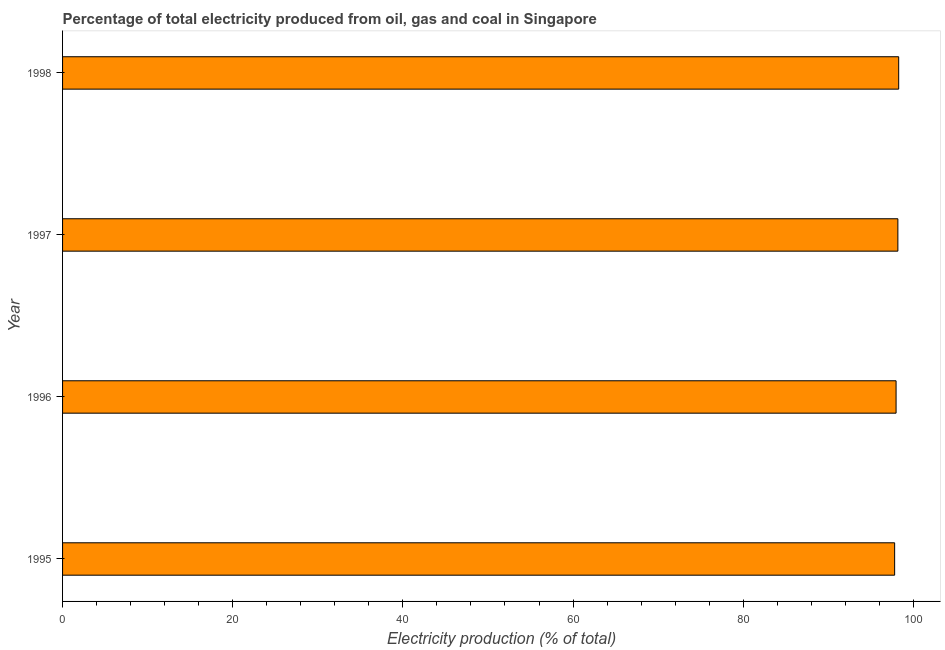Does the graph contain grids?
Keep it short and to the point. No. What is the title of the graph?
Provide a succinct answer. Percentage of total electricity produced from oil, gas and coal in Singapore. What is the label or title of the X-axis?
Give a very brief answer. Electricity production (% of total). What is the electricity production in 1996?
Provide a succinct answer. 97.97. Across all years, what is the maximum electricity production?
Offer a terse response. 98.27. Across all years, what is the minimum electricity production?
Provide a succinct answer. 97.8. In which year was the electricity production minimum?
Ensure brevity in your answer.  1995. What is the sum of the electricity production?
Make the answer very short. 392.22. What is the difference between the electricity production in 1995 and 1997?
Give a very brief answer. -0.38. What is the average electricity production per year?
Make the answer very short. 98.05. What is the median electricity production?
Offer a terse response. 98.07. In how many years, is the electricity production greater than 76 %?
Your answer should be compact. 4. Is the electricity production in 1995 less than that in 1998?
Your answer should be compact. Yes. What is the difference between the highest and the second highest electricity production?
Your response must be concise. 0.1. What is the difference between the highest and the lowest electricity production?
Your answer should be very brief. 0.48. In how many years, is the electricity production greater than the average electricity production taken over all years?
Provide a short and direct response. 2. How many bars are there?
Provide a succinct answer. 4. How many years are there in the graph?
Keep it short and to the point. 4. What is the difference between two consecutive major ticks on the X-axis?
Give a very brief answer. 20. What is the Electricity production (% of total) of 1995?
Your response must be concise. 97.8. What is the Electricity production (% of total) of 1996?
Your answer should be very brief. 97.97. What is the Electricity production (% of total) of 1997?
Your answer should be very brief. 98.18. What is the Electricity production (% of total) of 1998?
Offer a terse response. 98.27. What is the difference between the Electricity production (% of total) in 1995 and 1996?
Ensure brevity in your answer.  -0.17. What is the difference between the Electricity production (% of total) in 1995 and 1997?
Your answer should be compact. -0.38. What is the difference between the Electricity production (% of total) in 1995 and 1998?
Your answer should be compact. -0.48. What is the difference between the Electricity production (% of total) in 1996 and 1997?
Keep it short and to the point. -0.21. What is the difference between the Electricity production (% of total) in 1996 and 1998?
Provide a succinct answer. -0.31. What is the difference between the Electricity production (% of total) in 1997 and 1998?
Ensure brevity in your answer.  -0.09. What is the ratio of the Electricity production (% of total) in 1995 to that in 1996?
Offer a terse response. 1. What is the ratio of the Electricity production (% of total) in 1996 to that in 1997?
Give a very brief answer. 1. What is the ratio of the Electricity production (% of total) in 1997 to that in 1998?
Your response must be concise. 1. 